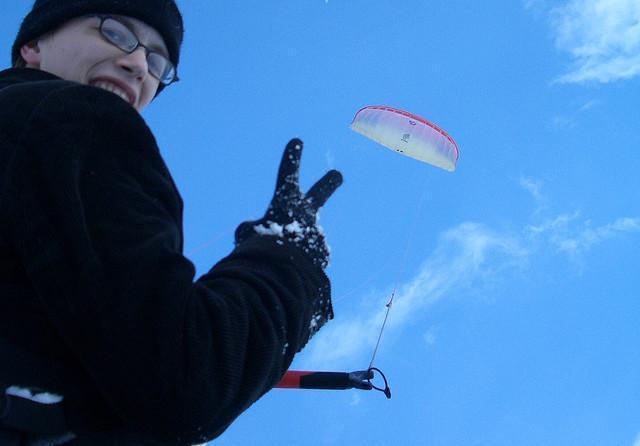How many people are in the picture?
Give a very brief answer. 1. How many boats have red painted on them?
Give a very brief answer. 0. 